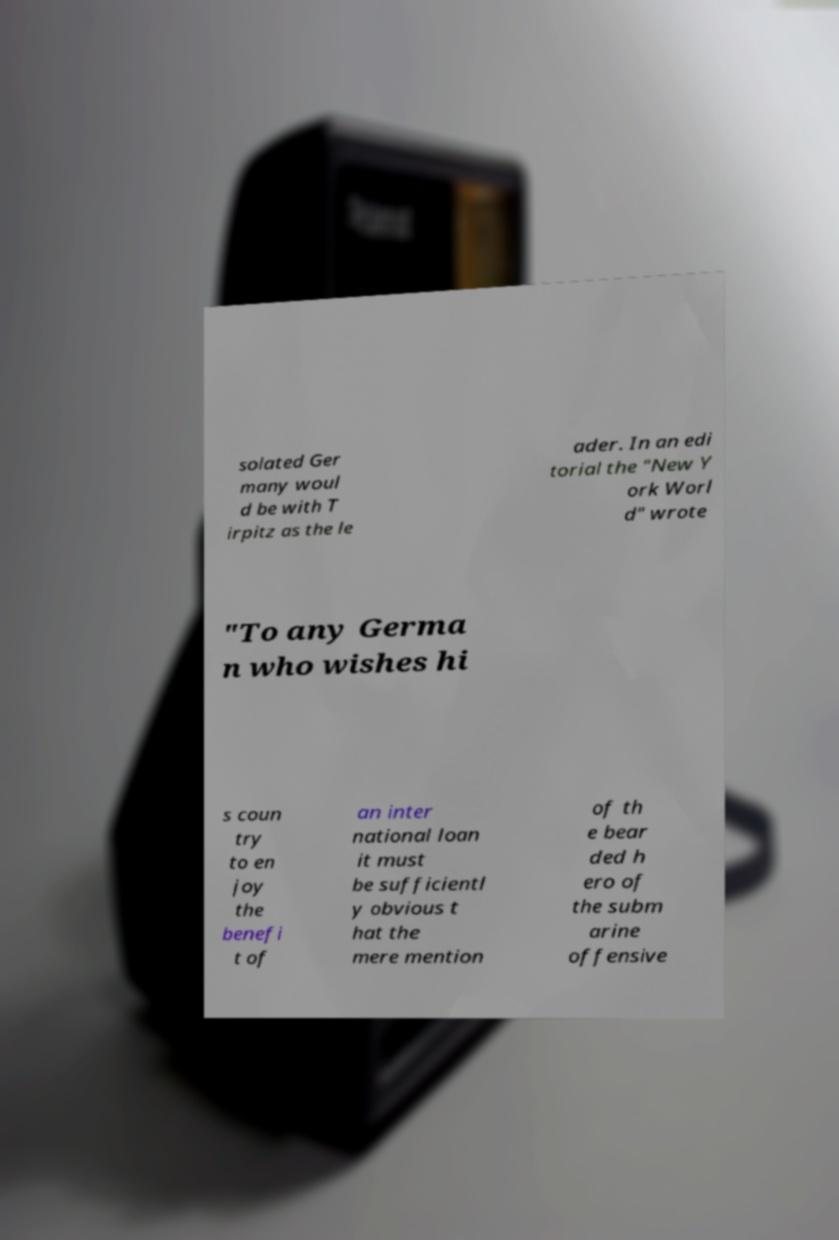Could you assist in decoding the text presented in this image and type it out clearly? solated Ger many woul d be with T irpitz as the le ader. In an edi torial the "New Y ork Worl d" wrote "To any Germa n who wishes hi s coun try to en joy the benefi t of an inter national loan it must be sufficientl y obvious t hat the mere mention of th e bear ded h ero of the subm arine offensive 